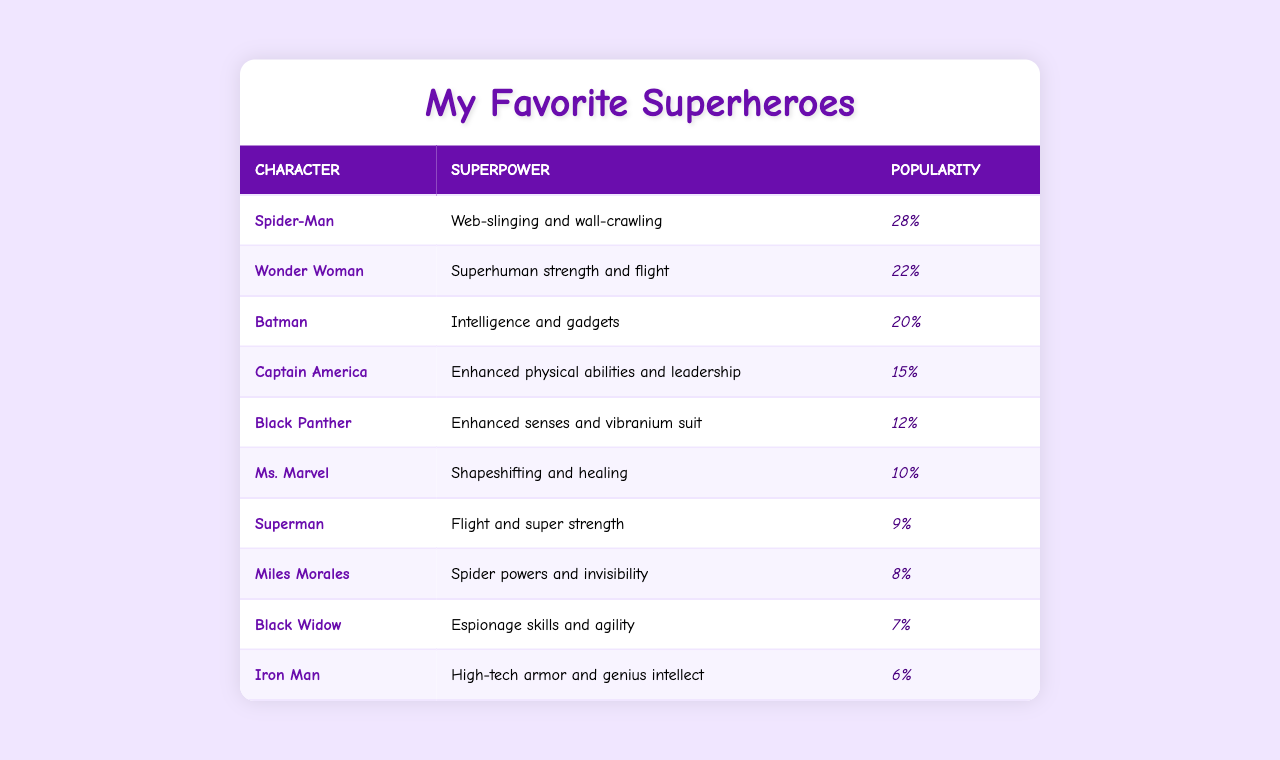What's the most popular comic book character among children? The table shows that Spider-Man has the highest popularity percentage at 28%.
Answer: Spider-Man Which character has the superpower of flight? The table lists Superman and Wonder Woman as characters with the superpower of flight.
Answer: Superman and Wonder Woman What is the popularity percentage of Black Panther? The table indicates that Black Panther has a popularity percentage of 12%.
Answer: 12% Which character is known for using gadgets? The table states that Batman is known for his intelligence and gadgets.
Answer: Batman What superpower does Captain America possess? According to the table, Captain America has enhanced physical abilities and leadership as superpowers.
Answer: Enhanced physical abilities and leadership Is Iron Man more popular than Black Widow? The table shows Iron Man with 6% popularity while Black Widow has 7%, making Black Widow more popular.
Answer: No What is the combined popularity of Spider-Man and Batman? Adding their popularity percentages together gives 28% (Spider-Man) + 20% (Batman) = 48%.
Answer: 48% Which comic book character has the least popularity? The table shows that Iron Man has the least popularity, with a percentage of 6%.
Answer: Iron Man How many characters have a popularity percentage above 15%? The characters with popularity above 15% are Spider-Man (28%), Wonder Woman (22%), and Batman (20). That’s three characters.
Answer: 3 What is the average popularity percentage of all the characters listed? To find the average, sum all the popularity percentages: 28 + 22 + 20 + 15 + 12 + 10 + 9 + 8 + 7 + 6 =  137. Then, divide by the number of characters, which is 10. So, 137/10 = 13.7%.
Answer: 13.7% 